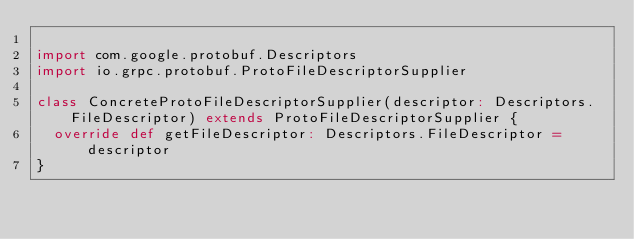Convert code to text. <code><loc_0><loc_0><loc_500><loc_500><_Scala_>
import com.google.protobuf.Descriptors
import io.grpc.protobuf.ProtoFileDescriptorSupplier

class ConcreteProtoFileDescriptorSupplier(descriptor: Descriptors.FileDescriptor) extends ProtoFileDescriptorSupplier {
  override def getFileDescriptor: Descriptors.FileDescriptor = descriptor
}
</code> 